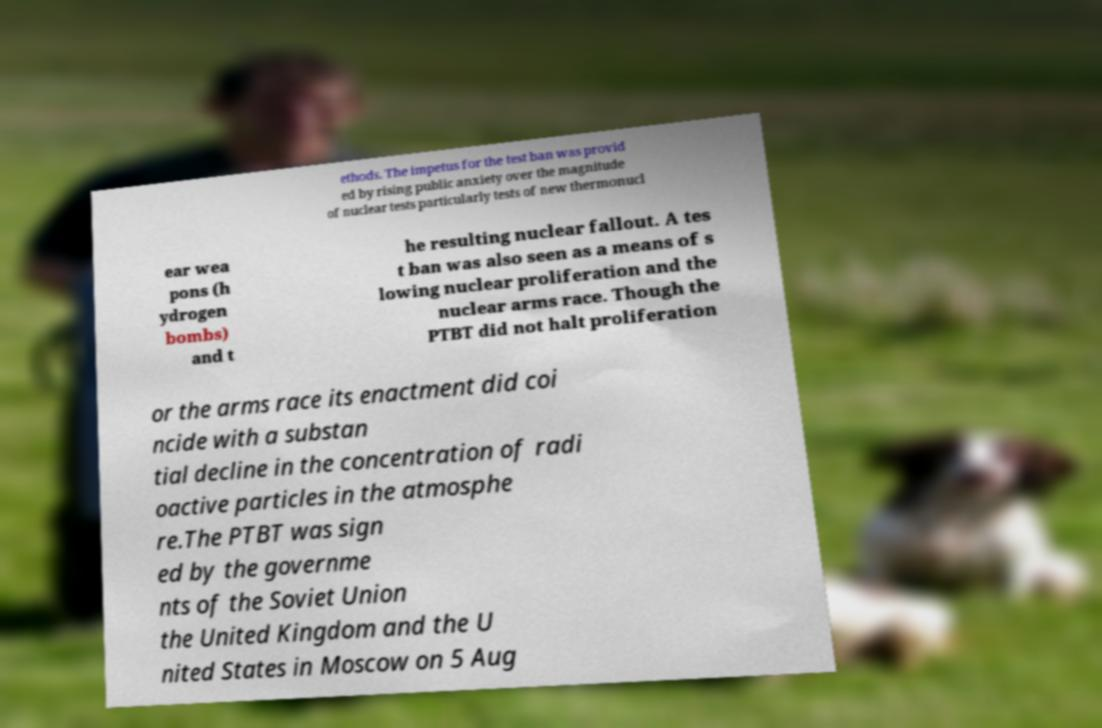For documentation purposes, I need the text within this image transcribed. Could you provide that? ethods. The impetus for the test ban was provid ed by rising public anxiety over the magnitude of nuclear tests particularly tests of new thermonucl ear wea pons (h ydrogen bombs) and t he resulting nuclear fallout. A tes t ban was also seen as a means of s lowing nuclear proliferation and the nuclear arms race. Though the PTBT did not halt proliferation or the arms race its enactment did coi ncide with a substan tial decline in the concentration of radi oactive particles in the atmosphe re.The PTBT was sign ed by the governme nts of the Soviet Union the United Kingdom and the U nited States in Moscow on 5 Aug 